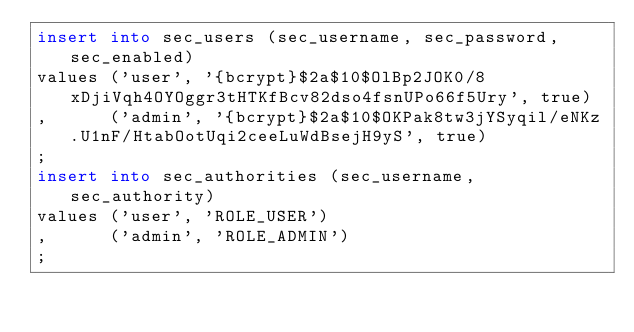<code> <loc_0><loc_0><loc_500><loc_500><_SQL_>insert into sec_users (sec_username, sec_password, sec_enabled)
values ('user', '{bcrypt}$2a$10$OlBp2JOK0/8xDjiVqh4OYOggr3tHTKfBcv82dso4fsnUPo66f5Ury', true)
,      ('admin', '{bcrypt}$2a$10$OKPak8tw3jYSyqil/eNKz.U1nF/HtabOotUqi2ceeLuWdBsejH9yS', true)
;
insert into sec_authorities (sec_username, sec_authority)
values ('user', 'ROLE_USER')
,      ('admin', 'ROLE_ADMIN')
;
</code> 